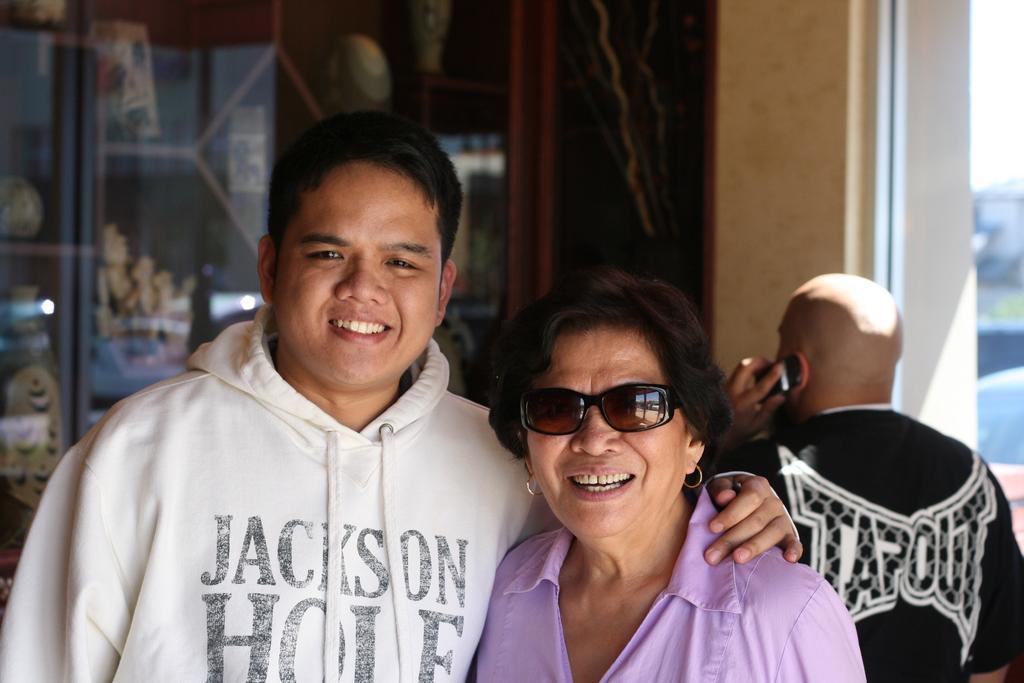Could you give a brief overview of what you see in this image? In this image we can see a man and a woman. They are smiling. Here we can see a person holding a mobile. In the background we can see glass, wall, and other objects. 